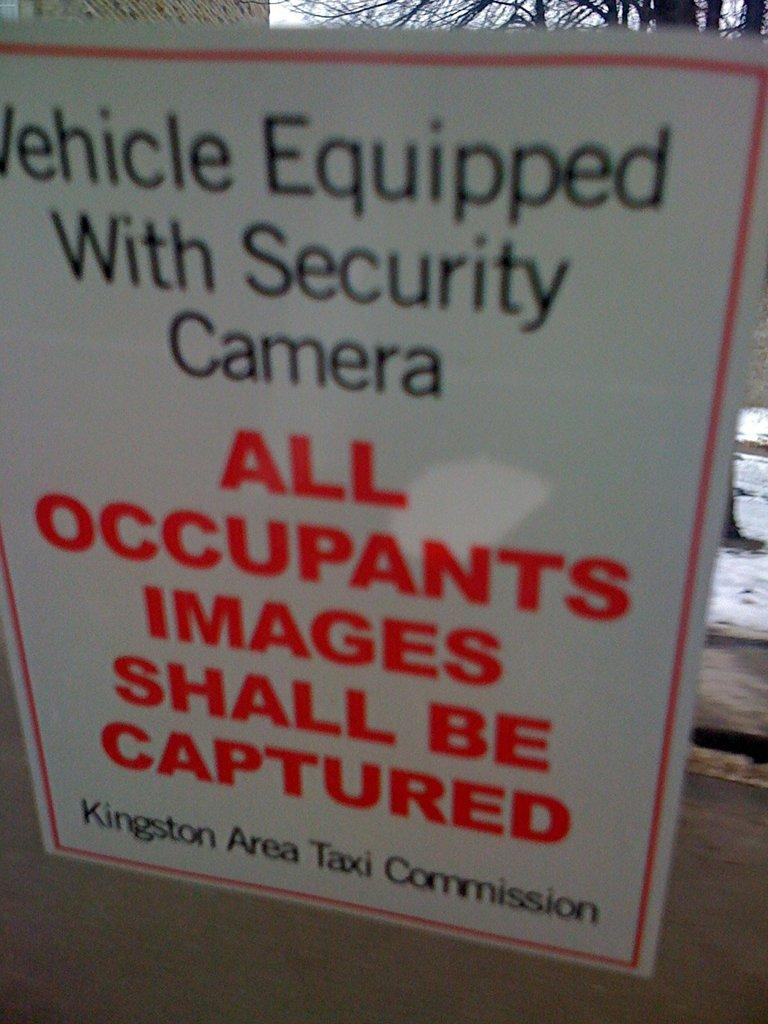<image>
Write a terse but informative summary of the picture. a warning sign that all images will be captured 